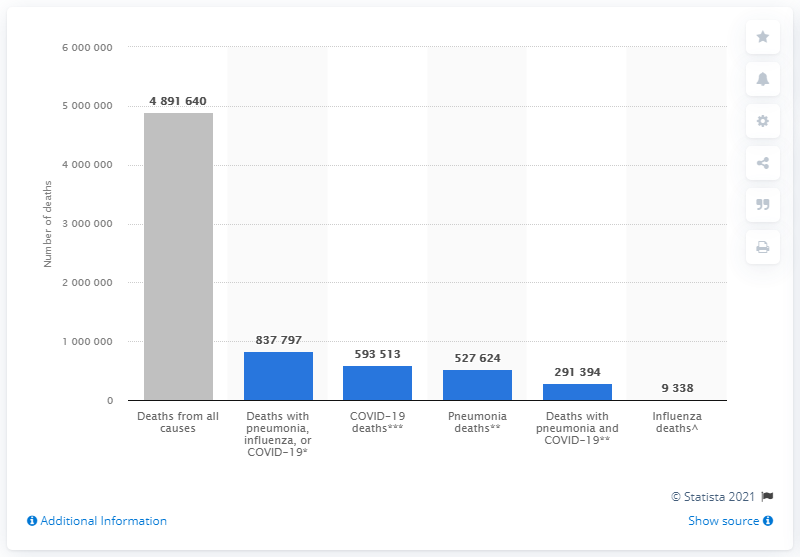List a handful of essential elements in this visual. During the period of January 1, 2020 and June 25, 2021, a total of 489,1640 people died from all causes. 